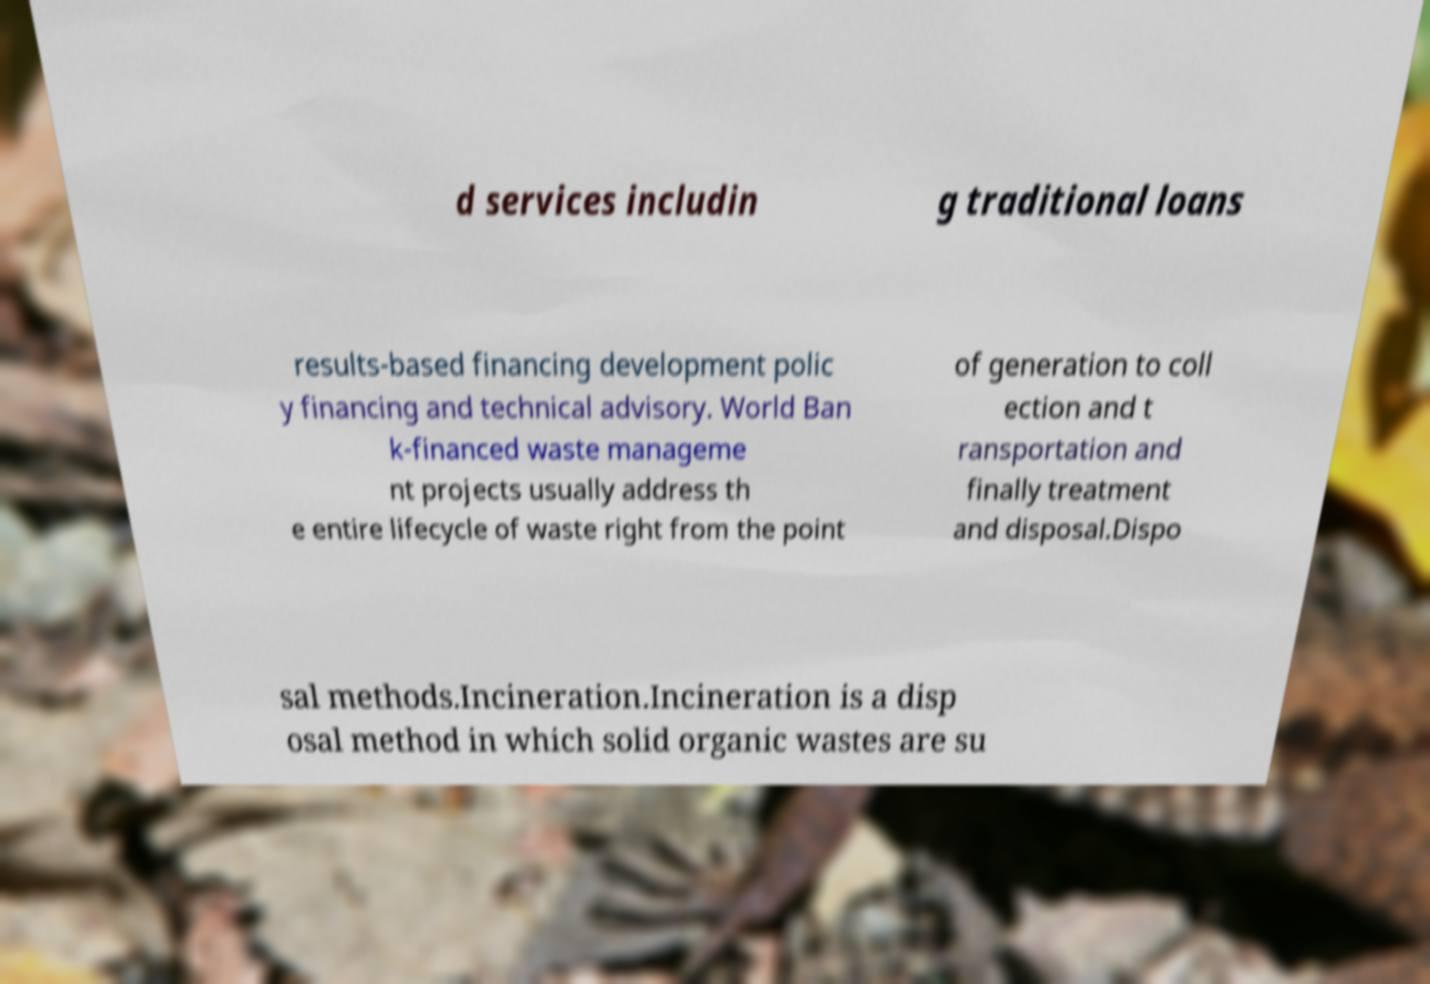Please read and relay the text visible in this image. What does it say? d services includin g traditional loans results-based financing development polic y financing and technical advisory. World Ban k-financed waste manageme nt projects usually address th e entire lifecycle of waste right from the point of generation to coll ection and t ransportation and finally treatment and disposal.Dispo sal methods.Incineration.Incineration is a disp osal method in which solid organic wastes are su 